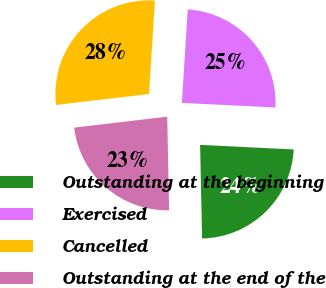<chart> <loc_0><loc_0><loc_500><loc_500><pie_chart><fcel>Outstanding at the beginning<fcel>Exercised<fcel>Cancelled<fcel>Outstanding at the end of the<nl><fcel>23.89%<fcel>24.78%<fcel>27.87%<fcel>23.46%<nl></chart> 